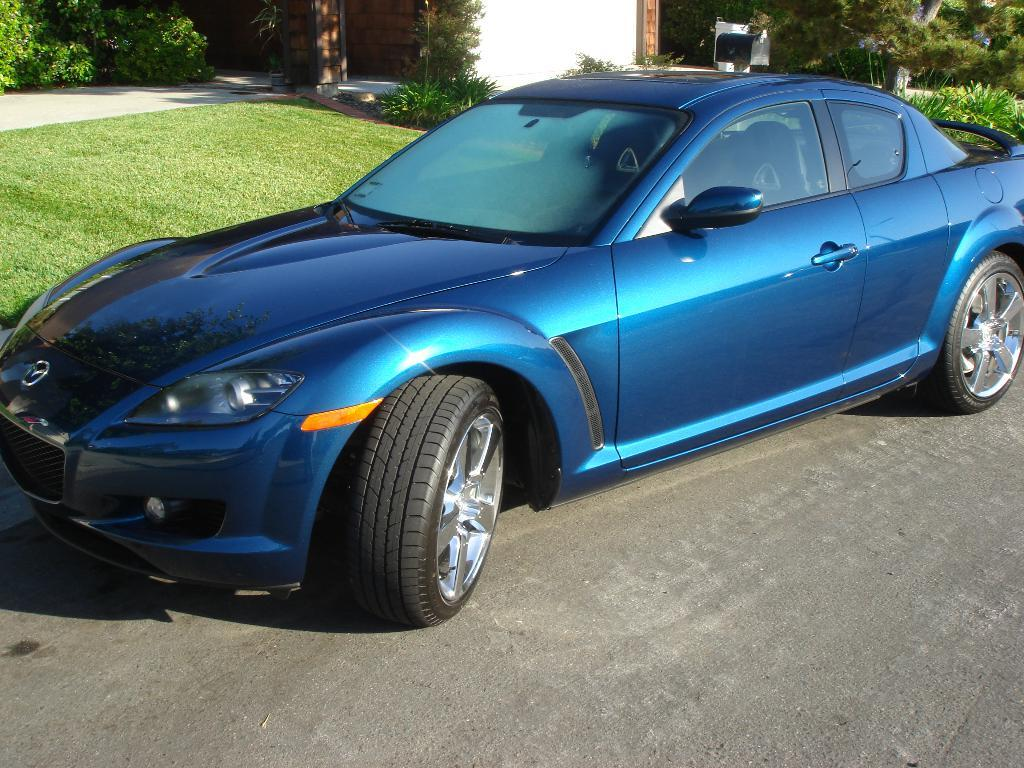What color is the car in the image? The car in the image is blue. Where is the car located in the image? The car is parked on the road. What can be seen in the background of the image? There is a house, trees, plants, and grass visible in the background of the image. What type of magic is the car performing in the image? There is no magic being performed by the car in the image; it is simply parked on the road. Who is the friend that the car is talking to in the image? There are no people or friends present in the image, only the car and the background elements. 